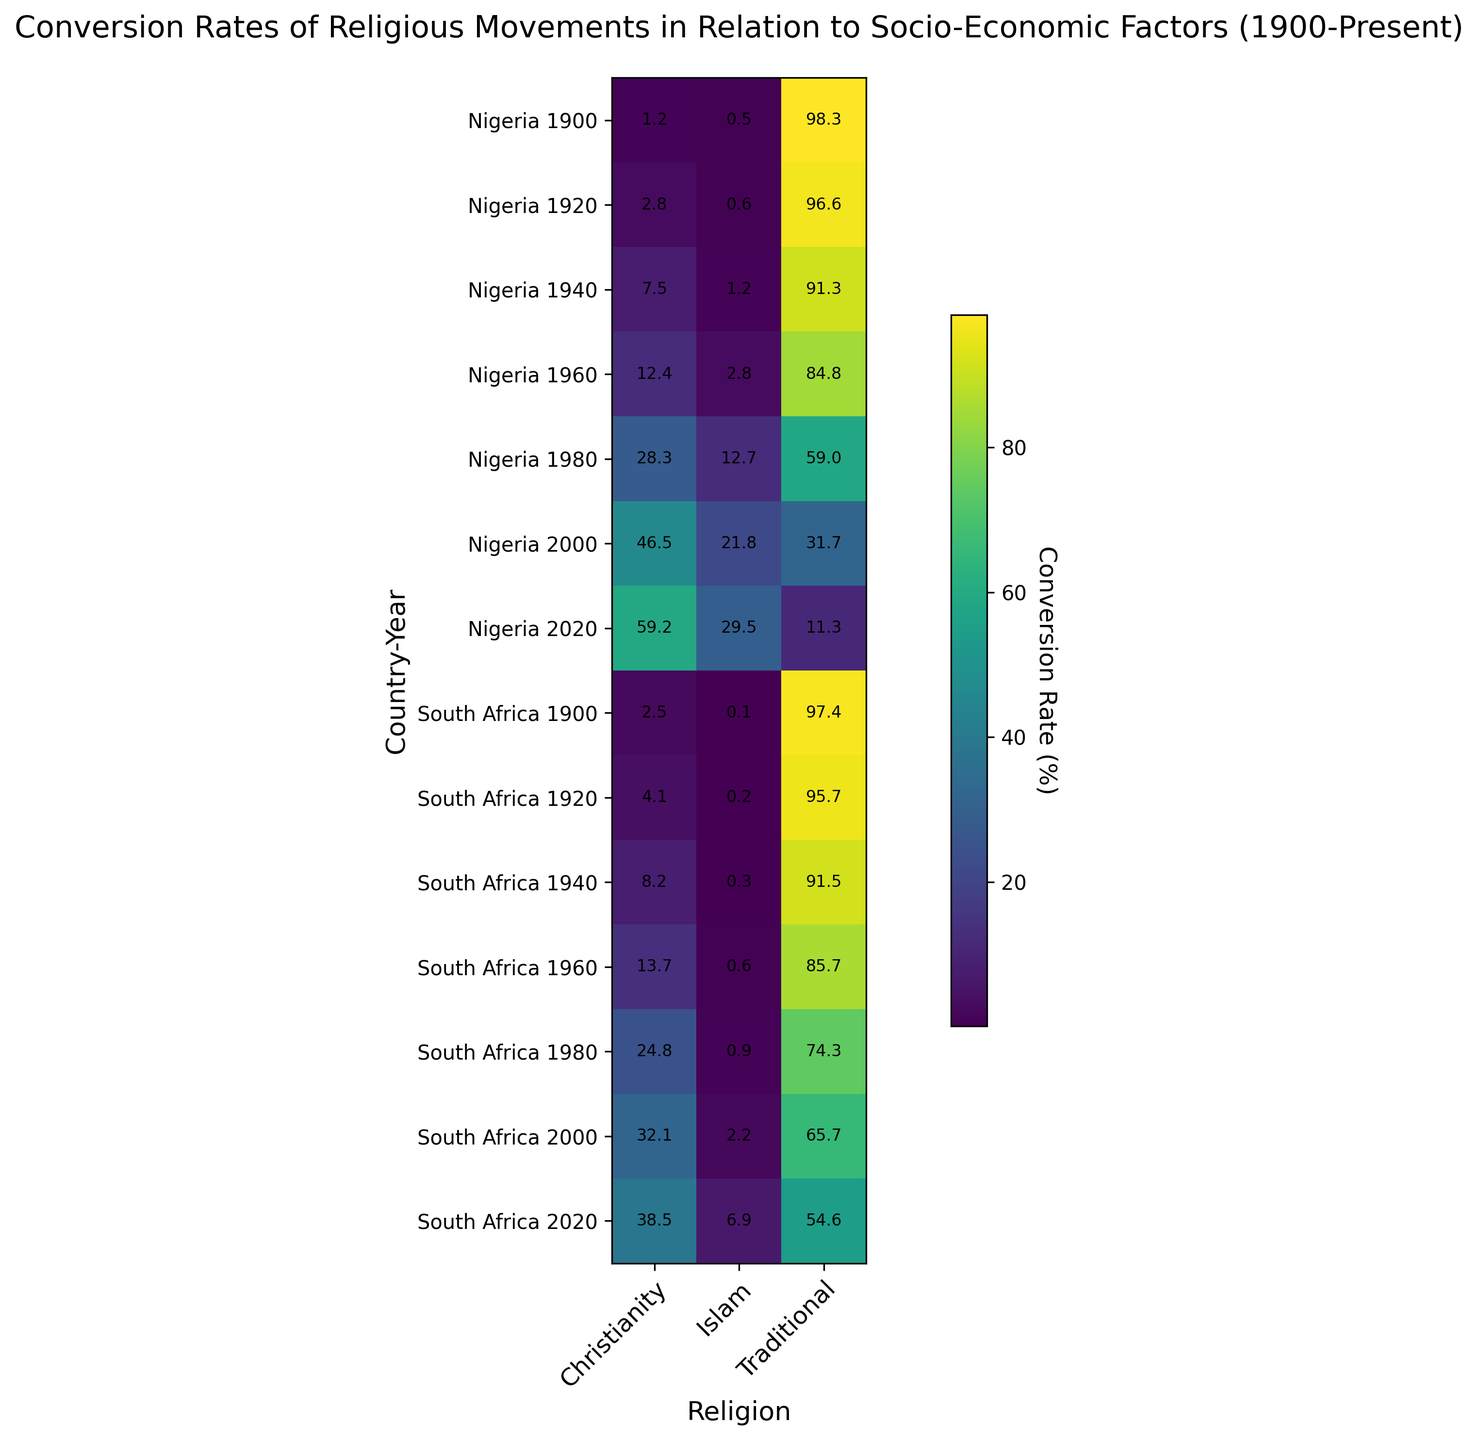What's the overall trend in the conversion rate of Christianity in Nigeria from 1900 to 2020? The conversion rate of Christianity in Nigeria increases over the years. Starting from 1.2 in 1900, it rises significantly to 59.2 in 2020. By visually scanning the data points for Nigeria, each subsequent year shows a higher conversion rate for Christianity.
Answer: Increasing Which country had a higher conversion rate for Islam in 1960, Nigeria or South Africa? To compare the conversion rate of Islam in 1960 between Nigeria and South Africa, we see that Nigeria has a conversion rate of 2.8, whereas South Africa has a rate of 0.6. Nigeria's rate is visibly higher.
Answer: Nigeria How did the conversion rates for Traditional religions change in South Africa from 1900 to 2020? In South Africa, the conversion rate for Traditional religions decreases over the years. It starts at 97.4 in 1900 and drops significantly to 54.6 by 2020. Each observed year shows a lower conversion rate compared to the previous one.
Answer: Decreasing What is the difference in the conversion rate of Christianity between Nigeria and South Africa in 1980? For 1980, Nigeria's conversion rate for Christianity is 28.3, while South Africa's rate is 24.8. The difference is calculated as 28.3 - 24.8 = 3.5.
Answer: 3.5 In which year did Nigeria have its highest conversion rate for Islam? By scanning through the conversion rates for Islam in Nigeria across all the years, the highest value of 29.5 is observed in the year 2020.
Answer: 2020 On average, how do the conversion rates for Christianity in South Africa compare between 1900 and 2000? In 1900, the conversion rate for Christianity in South Africa is 2.5, and in 2000 it is 32.1. The average of these two values is (2.5+32.1)/2 = 17.3.
Answer: 17.3 Which country and year combination has the highest conversion rate for a Traditional religion? By scanning the heatmap, the highest conversion rate for Traditional religions is observed for Nigeria in 1900 with a rate of 98.3.
Answer: Nigeria 1900 How do the socio-economic indices relate to changes in the conversion rates for Traditional religions from 1920 to 2000 in South Africa? The socio-economic index increases from 38 in 1920 to 75 in 2000. In contrast, the conversion rate for Traditional religions decreases from 95.7 to 65.7 over the same period. This suggests an inverse relationship — as the socio-economic index goes up, the conversion rate for Traditional religions goes down.
Answer: Inversely related 